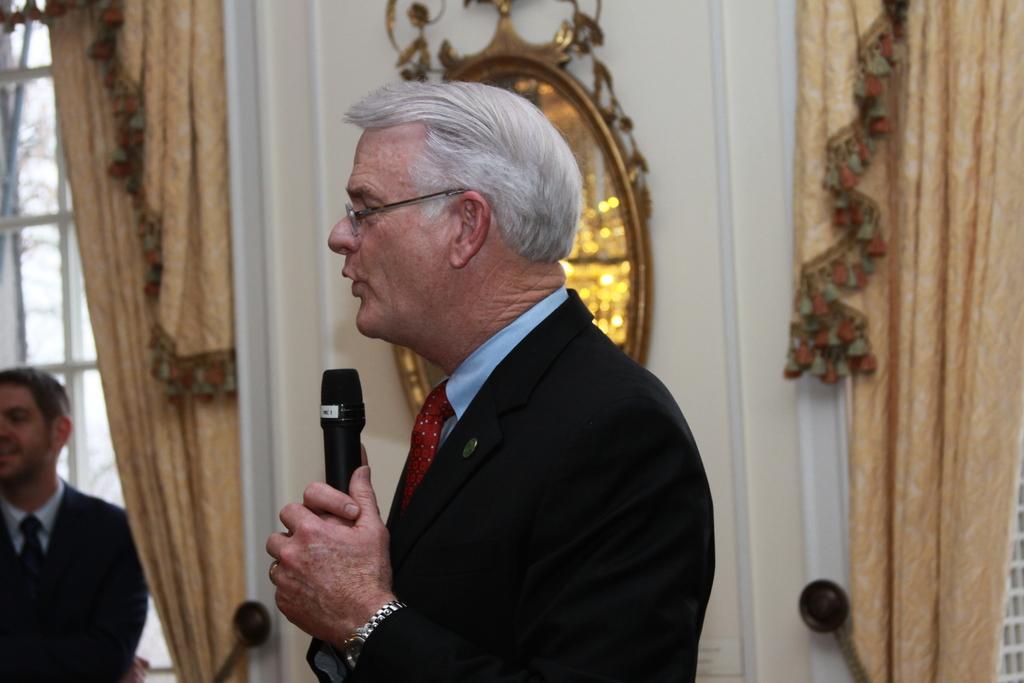Can you describe this image briefly? In this image a man is talking he is wearing a blue suit he is holding one mic. In the background on the wall there is curtain. In the left another person is standing. There is a window in the left. 